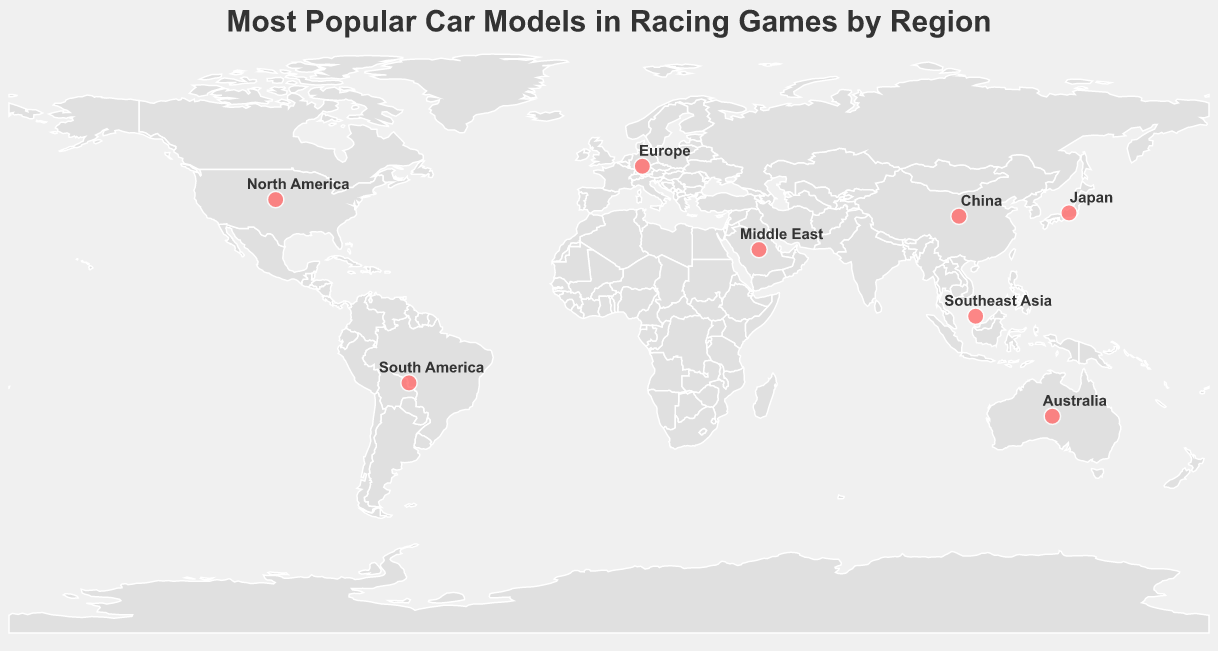What is the most popular car model in North America? According to the figure, the tooltip indicates the most popular car model in North America is the Ford Mustang.
Answer: Ford Mustang Which regions favor an SUV or off-road vehicle, based on the most popular car models? Analyzing the figure, the most popular models in the Middle East and South America are SUVs or off-road vehicles. The Middle East’s favorite is the Nissan Patrol, and South America’s is the Volkswagen Gol.
Answer: Middle East, South America What is the geographical trend for the popularity of Japanese car brands? By examining the figure, Japanese car brands are most popular in Japan and Southeast Asia, as seen with the Nissan GT-R in Japan and the Toyota Corolla in Southeast Asia.
Answer: Japan, Southeast Asia Compare the number of European car models that appear as the most popular in their respective regions with those from American brands. From the figure, European car models are the most popular in Europe (BMW M3) and China (Hongqi H9), counting 2. American models are most popular in North America (Ford Mustang) and Australia (Ford Falcon), also counting 2.
Answer: Both have two regions where they are the most popular Which region has the most different brands in the top three popular car models? By examining each region's top three car models from the figure, Europe has cars from three different brands: BMW (BMW M3), Audi (Audi RS6), and Mercedes-AMG (Mercedes-AMG C63).
Answer: Europe Between North America and Southeast Asia, which region has a higher representation of Japanese car models in the top three? From the figure, Southeast Asia has one Japanese model (Mitsubishi Lancer Evolution), whereas North America has none.
Answer: Southeast Asia What commonality can be observed in the top three car models in Japan? Observing the figure, all top three car models in Japan (Nissan GT-R, Toyota Supra, Mazda RX-7) are high-performance sports cars.
Answer: High-performance sports cars Based on the plot, which region's most popular car model is from a domestic manufacturer? Several regions have a domestic manufacturer as the most popular car model. For instance, the Ford Mustang in North America, the Nissan GT-R in Japan, and the Hongqi H9 in China.
Answer: North America, Japan, China How does the popularity of American car models differ between Australia and North America? The figure shows that while the most popular car model in North America is the Ford Mustang, in Australia, it is the Holden Commodore, with a U.S. model (Ford Falcon) being second. This indicates a stronger local brand preference in Australia.
Answer: North America: Ford Mustang, Australia: Holden Commodore (American cars less popular) Which region has the most diverse top three car models when considering the types of vehicles (sports cars, sedans, SUVs, etc.)? By looking at the types of vehicles in each region, Europe shows diversity in its top three most popular car models, which include a sports car (BMW M3), a high-performance sedan (Audi RS6), and a luxury sedan (Mercedes-AMG C63).
Answer: Europe 